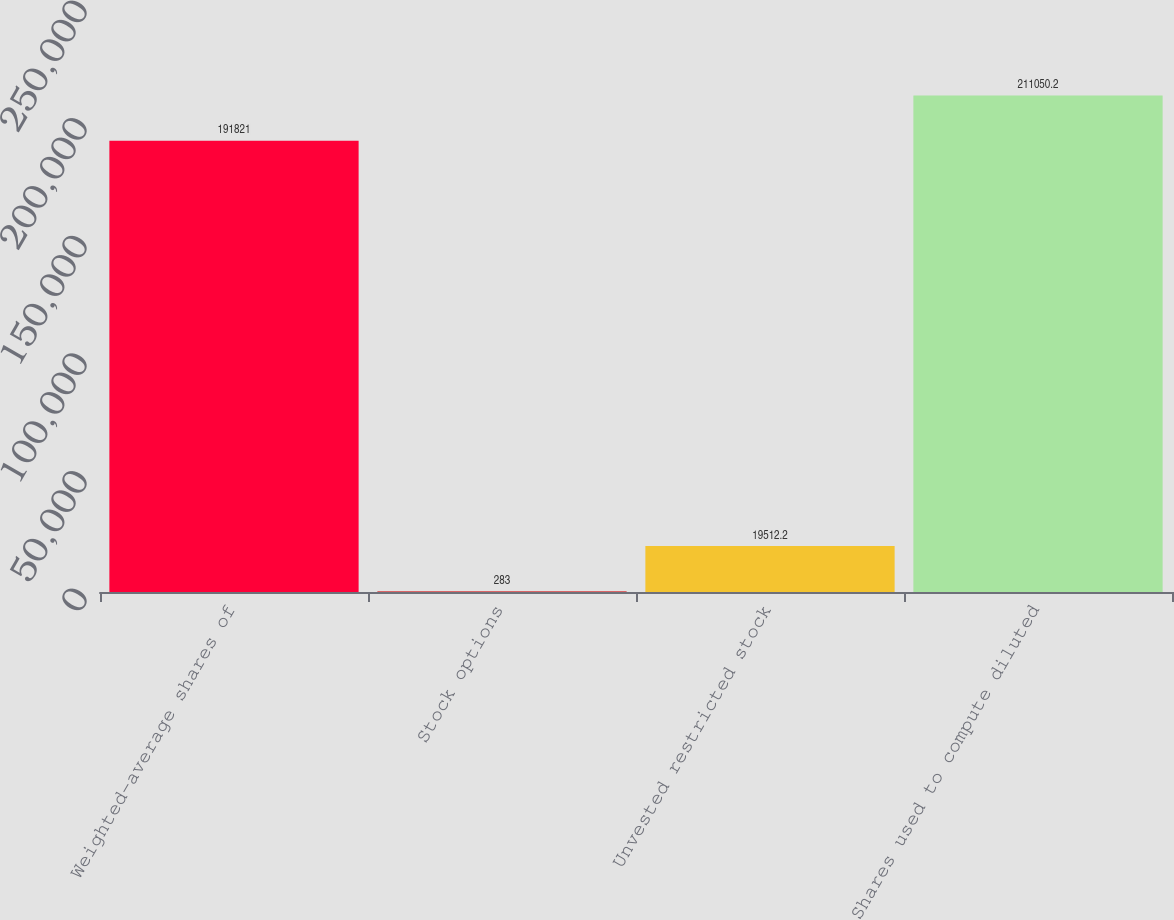Convert chart to OTSL. <chart><loc_0><loc_0><loc_500><loc_500><bar_chart><fcel>Weighted-average shares of<fcel>Stock options<fcel>Unvested restricted stock<fcel>Shares used to compute diluted<nl><fcel>191821<fcel>283<fcel>19512.2<fcel>211050<nl></chart> 